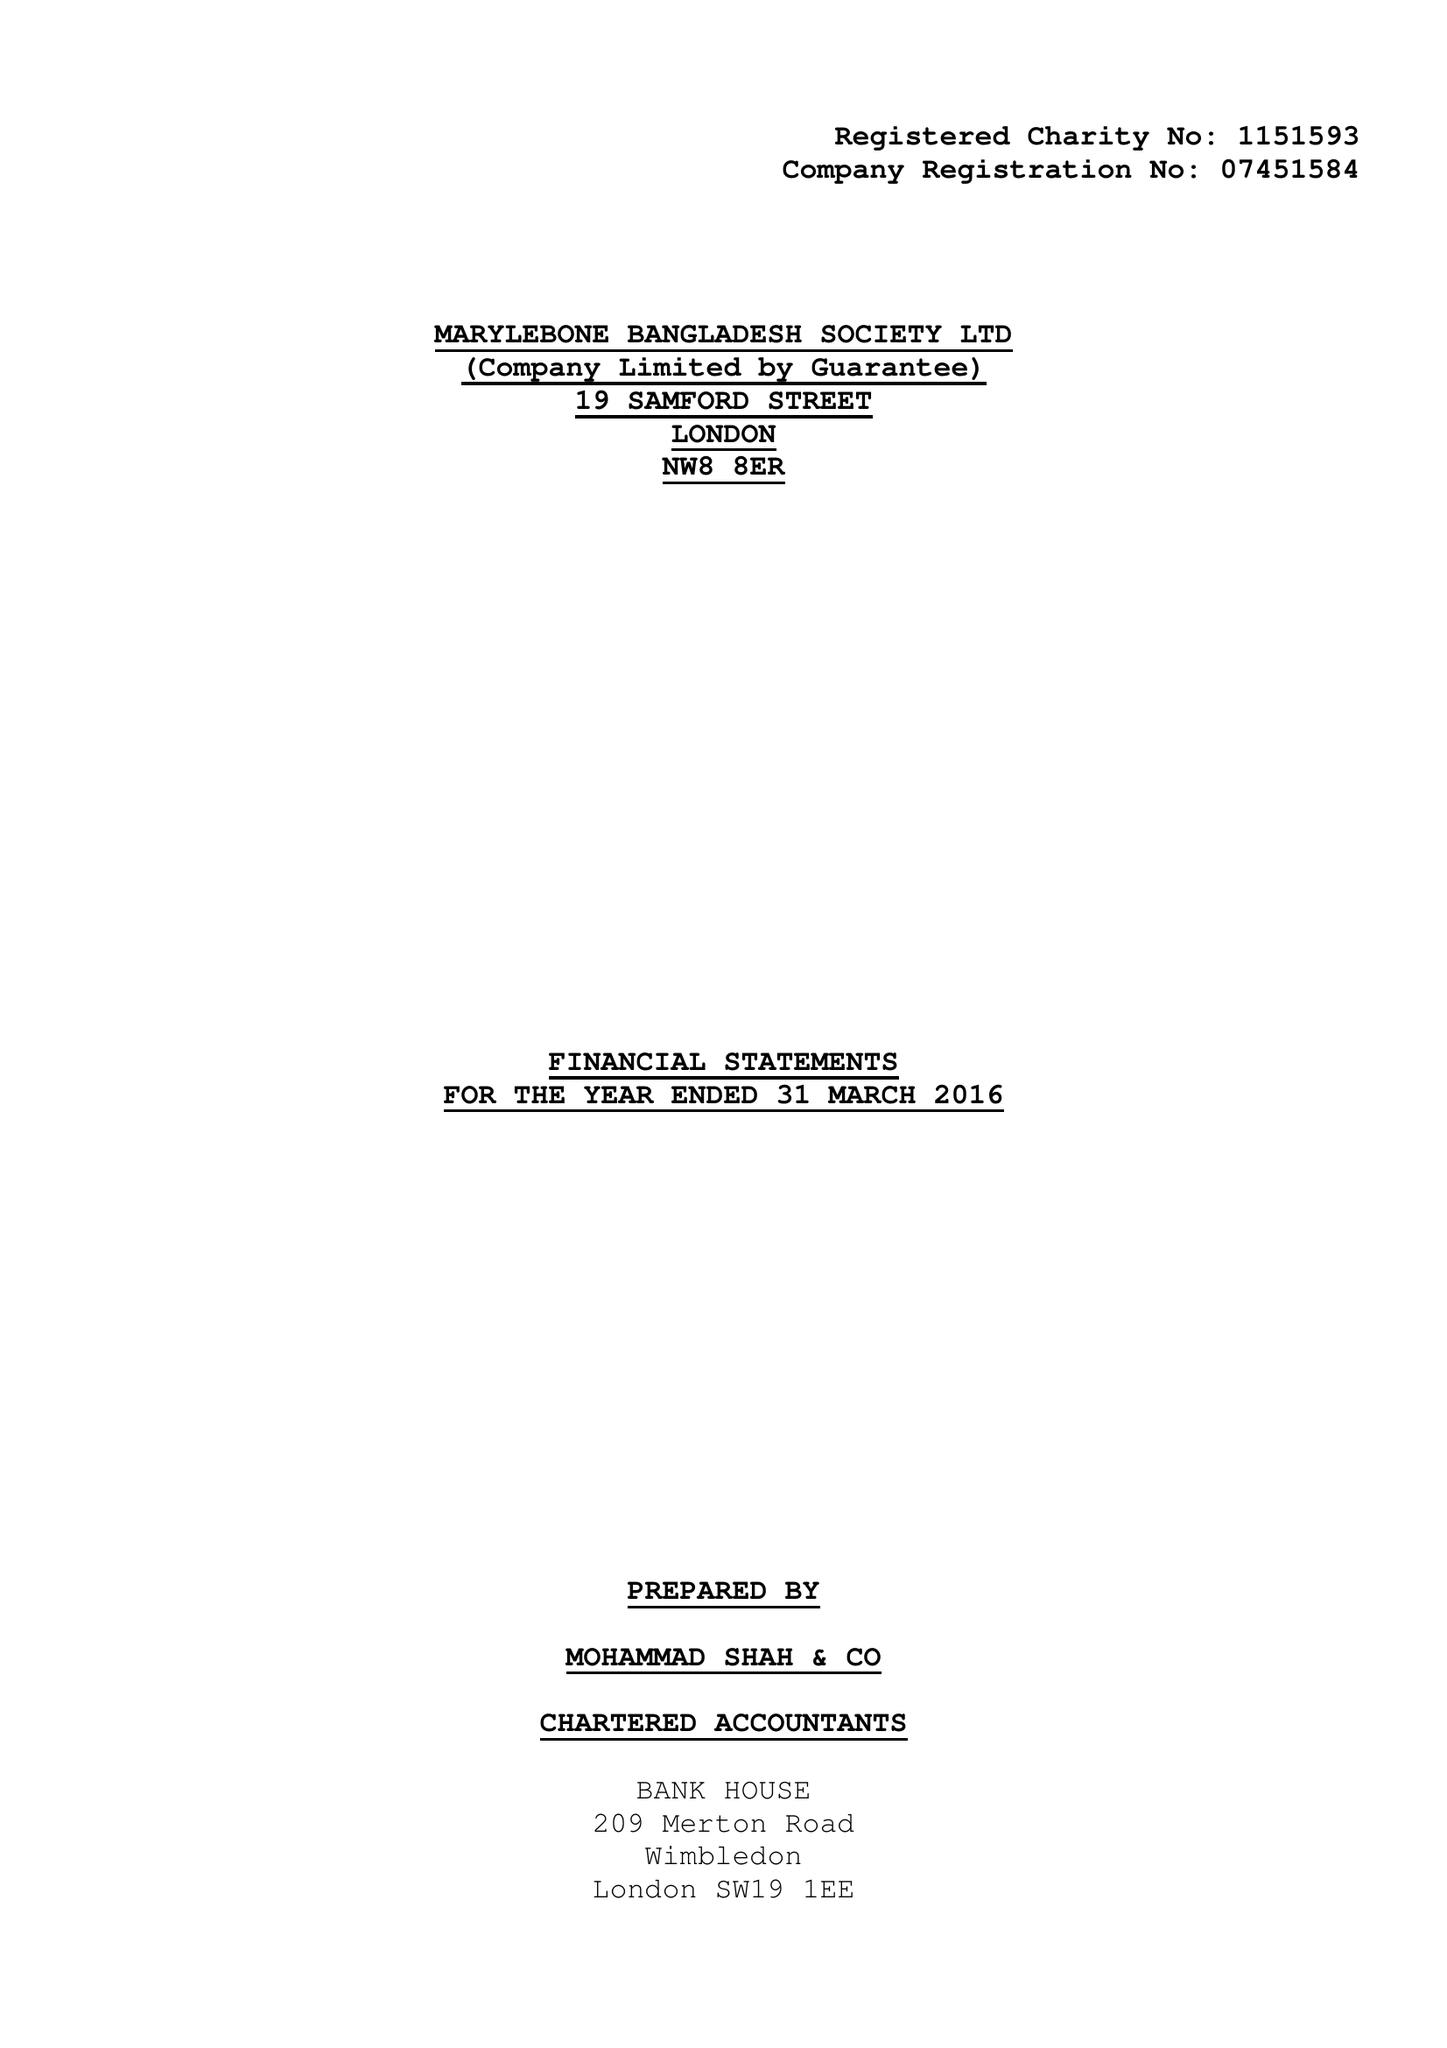What is the value for the address__post_town?
Answer the question using a single word or phrase. LONDON 